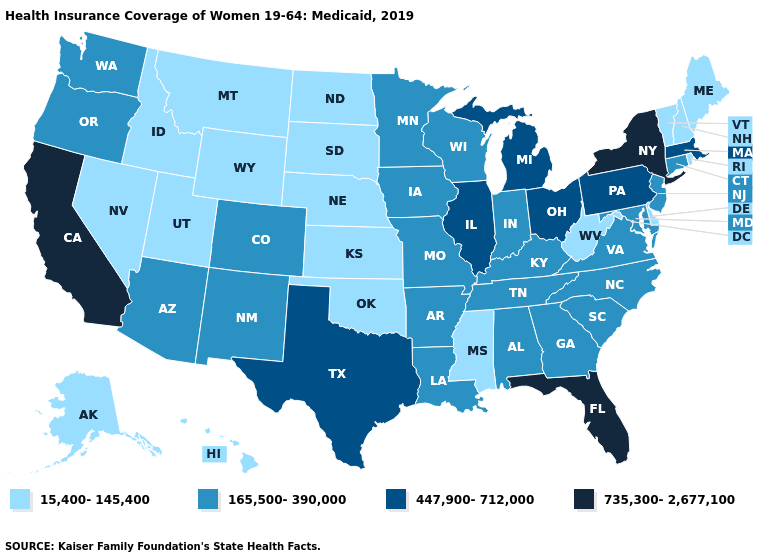Does the map have missing data?
Quick response, please. No. Does Missouri have the same value as Washington?
Concise answer only. Yes. Name the states that have a value in the range 15,400-145,400?
Short answer required. Alaska, Delaware, Hawaii, Idaho, Kansas, Maine, Mississippi, Montana, Nebraska, Nevada, New Hampshire, North Dakota, Oklahoma, Rhode Island, South Dakota, Utah, Vermont, West Virginia, Wyoming. Name the states that have a value in the range 447,900-712,000?
Answer briefly. Illinois, Massachusetts, Michigan, Ohio, Pennsylvania, Texas. Which states have the lowest value in the USA?
Answer briefly. Alaska, Delaware, Hawaii, Idaho, Kansas, Maine, Mississippi, Montana, Nebraska, Nevada, New Hampshire, North Dakota, Oklahoma, Rhode Island, South Dakota, Utah, Vermont, West Virginia, Wyoming. What is the value of Tennessee?
Concise answer only. 165,500-390,000. Does Kansas have a lower value than Massachusetts?
Quick response, please. Yes. What is the highest value in the South ?
Answer briefly. 735,300-2,677,100. What is the value of West Virginia?
Concise answer only. 15,400-145,400. Name the states that have a value in the range 15,400-145,400?
Be succinct. Alaska, Delaware, Hawaii, Idaho, Kansas, Maine, Mississippi, Montana, Nebraska, Nevada, New Hampshire, North Dakota, Oklahoma, Rhode Island, South Dakota, Utah, Vermont, West Virginia, Wyoming. What is the highest value in the USA?
Answer briefly. 735,300-2,677,100. Does Kansas have the lowest value in the MidWest?
Give a very brief answer. Yes. Among the states that border Rhode Island , which have the highest value?
Keep it brief. Massachusetts. Which states have the lowest value in the USA?
Be succinct. Alaska, Delaware, Hawaii, Idaho, Kansas, Maine, Mississippi, Montana, Nebraska, Nevada, New Hampshire, North Dakota, Oklahoma, Rhode Island, South Dakota, Utah, Vermont, West Virginia, Wyoming. What is the value of Indiana?
Write a very short answer. 165,500-390,000. 